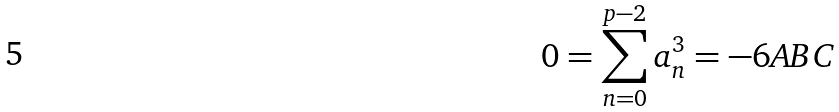<formula> <loc_0><loc_0><loc_500><loc_500>0 = \sum _ { n = 0 } ^ { p - 2 } a _ { n } ^ { 3 } = - 6 A B C</formula> 